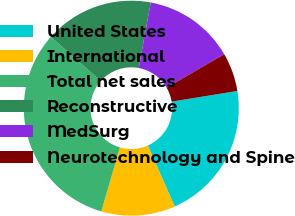<chart> <loc_0><loc_0><loc_500><loc_500><pie_chart><fcel>United States<fcel>International<fcel>Total net sales<fcel>Reconstructive<fcel>MedSurg<fcel>Neurotechnology and Spine<nl><fcel>20.95%<fcel>11.1%<fcel>32.05%<fcel>16.35%<fcel>13.73%<fcel>5.81%<nl></chart> 